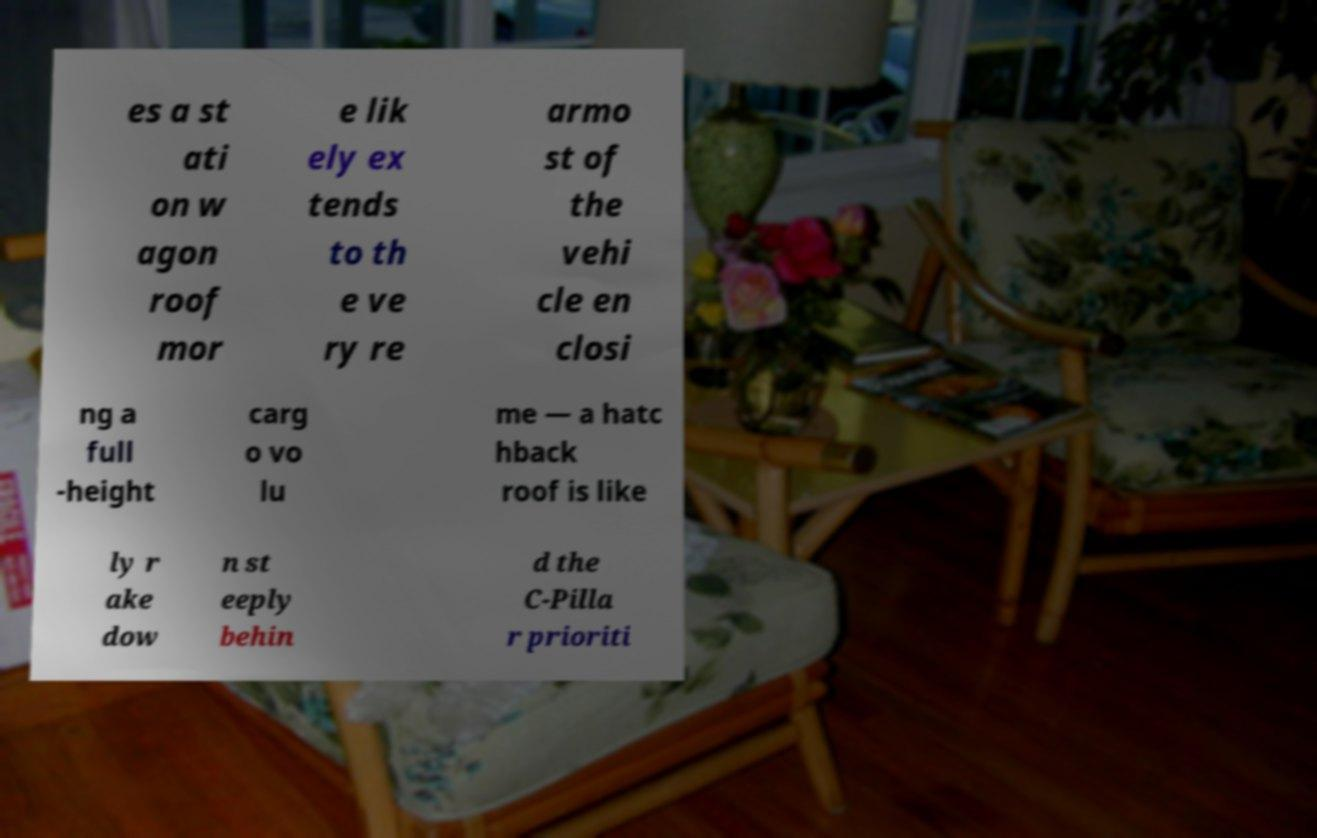Please read and relay the text visible in this image. What does it say? es a st ati on w agon roof mor e lik ely ex tends to th e ve ry re armo st of the vehi cle en closi ng a full -height carg o vo lu me — a hatc hback roof is like ly r ake dow n st eeply behin d the C-Pilla r prioriti 